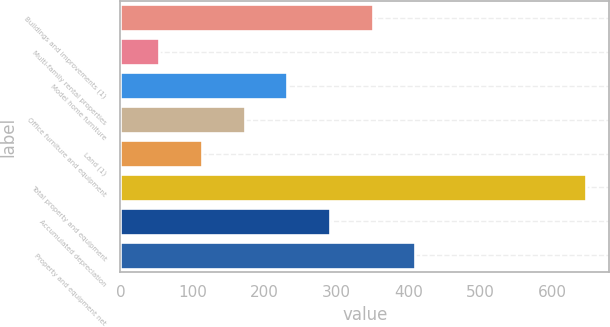Convert chart. <chart><loc_0><loc_0><loc_500><loc_500><bar_chart><fcel>Buildings and improvements (1)<fcel>Multi-family rental properties<fcel>Model home furniture<fcel>Office furniture and equipment<fcel>Land (1)<fcel>Total property and equipment<fcel>Accumulated depreciation<fcel>Property and equipment net<nl><fcel>349.95<fcel>54.1<fcel>231.61<fcel>172.44<fcel>113.27<fcel>645.8<fcel>290.78<fcel>409.12<nl></chart> 